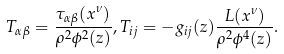Convert formula to latex. <formula><loc_0><loc_0><loc_500><loc_500>T _ { \alpha \beta } = \frac { \tau _ { \alpha \beta } ( x ^ { \nu } ) } { \rho ^ { 2 } \phi ^ { 2 } ( z ) } , T _ { i j } = - g _ { i j } ( z ) \frac { L ( x ^ { \nu } ) } { \rho ^ { 2 } \phi ^ { 4 } ( z ) } .</formula> 